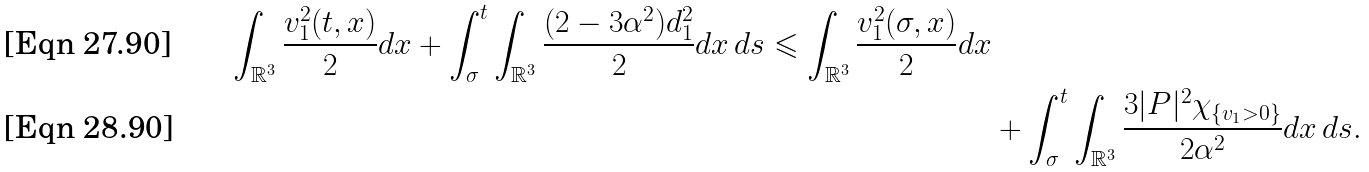Convert formula to latex. <formula><loc_0><loc_0><loc_500><loc_500>\int _ { \mathbb { R } ^ { 3 } } \frac { v _ { 1 } ^ { 2 } ( t , x ) } { 2 } d x + \int _ { \sigma } ^ { t } \int _ { \mathbb { R } ^ { 3 } } \frac { ( 2 - 3 \alpha ^ { 2 } ) d _ { 1 } ^ { 2 } } { 2 } d x \, d s \leqslant \int _ { \mathbb { R } ^ { 3 } } \frac { v _ { 1 } ^ { 2 } ( \sigma , x ) } { 2 } d x \\ & + \int _ { \sigma } ^ { t } \int _ { \mathbb { R } ^ { 3 } } \frac { 3 | P | ^ { 2 } \chi _ { \{ v _ { 1 } > 0 \} } } { 2 \alpha ^ { 2 } } d x \, d s .</formula> 